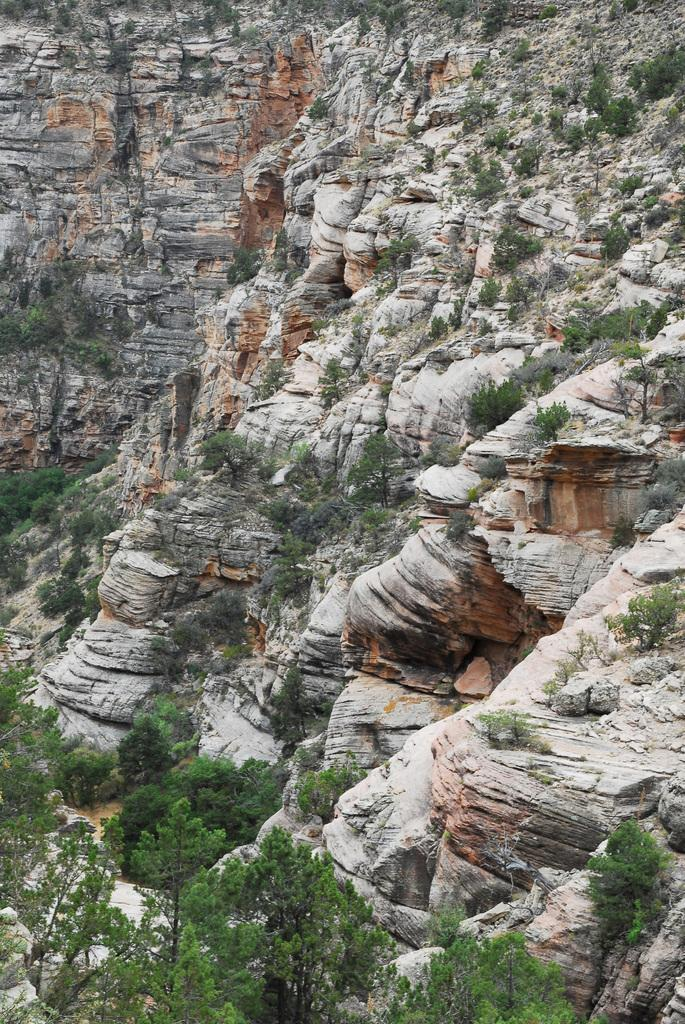Where was the image taken? The image was taken outdoors. What type of natural features can be seen in the image? There are many rocks, trees, and plants visible in the image. What advice is given by the rocks in the image? There is no advice given by the rocks in the image, as rocks are inanimate objects and cannot provide advice. 